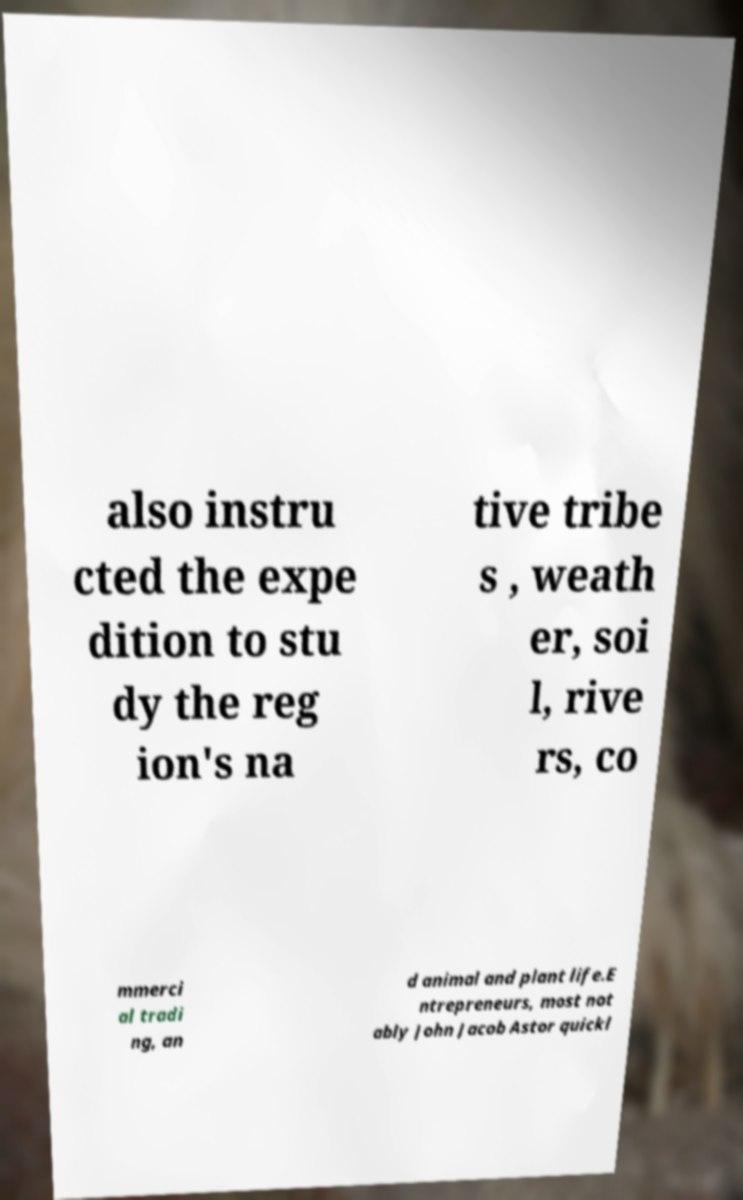Could you assist in decoding the text presented in this image and type it out clearly? also instru cted the expe dition to stu dy the reg ion's na tive tribe s , weath er, soi l, rive rs, co mmerci al tradi ng, an d animal and plant life.E ntrepreneurs, most not ably John Jacob Astor quickl 